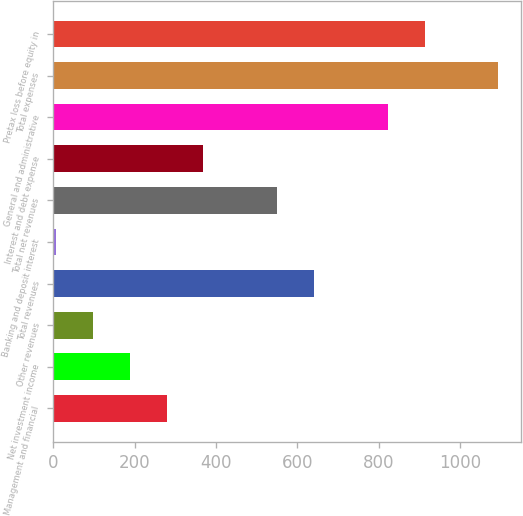Convert chart. <chart><loc_0><loc_0><loc_500><loc_500><bar_chart><fcel>Management and financial<fcel>Net investment income<fcel>Other revenues<fcel>Total revenues<fcel>Banking and deposit interest<fcel>Total net revenues<fcel>Interest and debt expense<fcel>General and administrative<fcel>Total expenses<fcel>Pretax loss before equity in<nl><fcel>278.8<fcel>188.2<fcel>97.6<fcel>641.2<fcel>7<fcel>550.6<fcel>369.4<fcel>822.4<fcel>1094.2<fcel>913<nl></chart> 